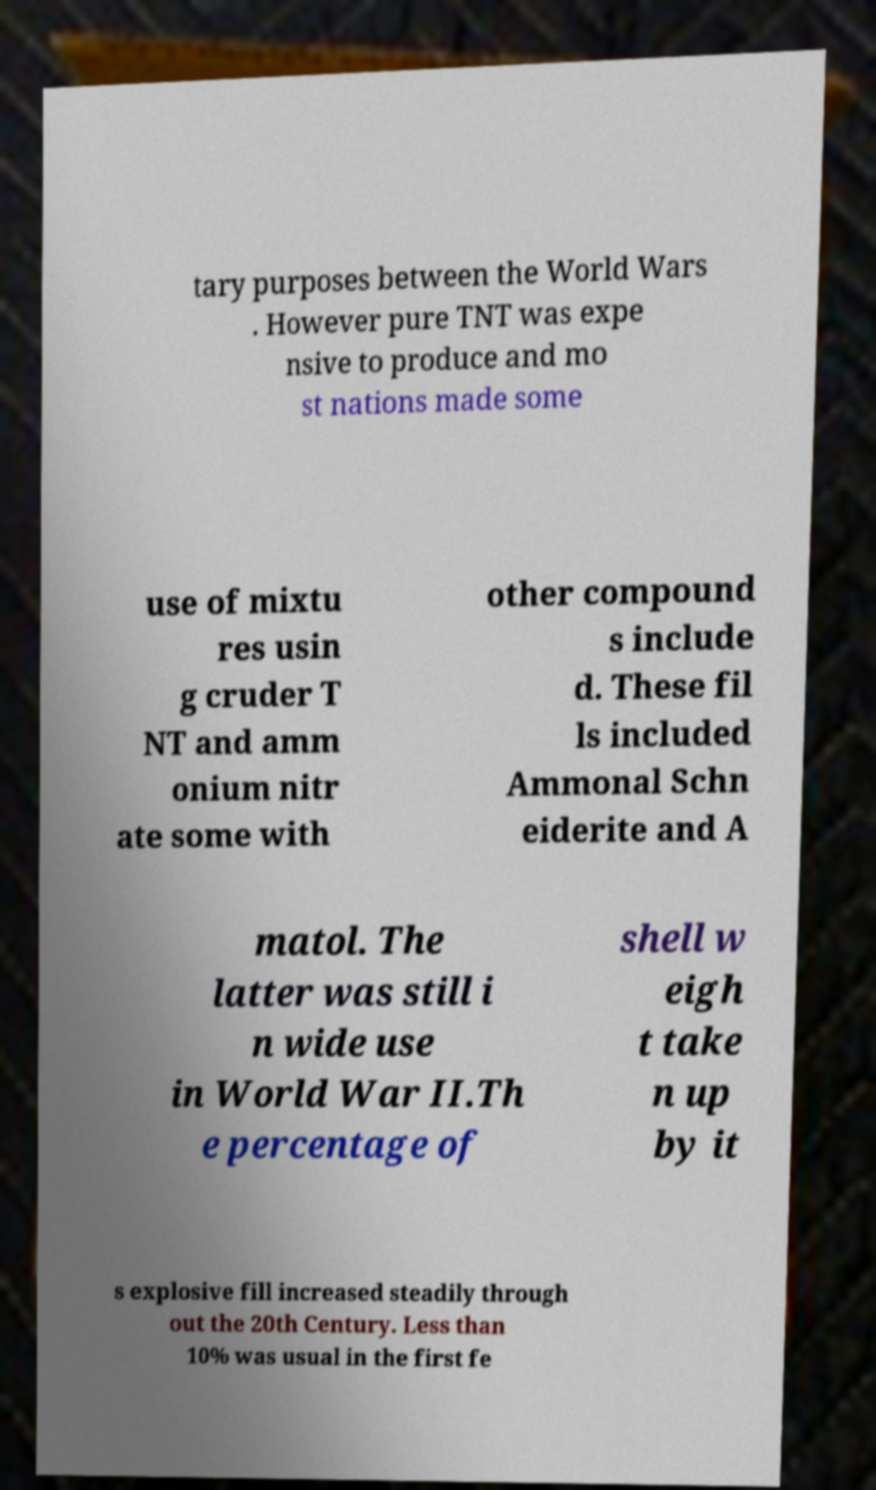I need the written content from this picture converted into text. Can you do that? tary purposes between the World Wars . However pure TNT was expe nsive to produce and mo st nations made some use of mixtu res usin g cruder T NT and amm onium nitr ate some with other compound s include d. These fil ls included Ammonal Schn eiderite and A matol. The latter was still i n wide use in World War II.Th e percentage of shell w eigh t take n up by it s explosive fill increased steadily through out the 20th Century. Less than 10% was usual in the first fe 